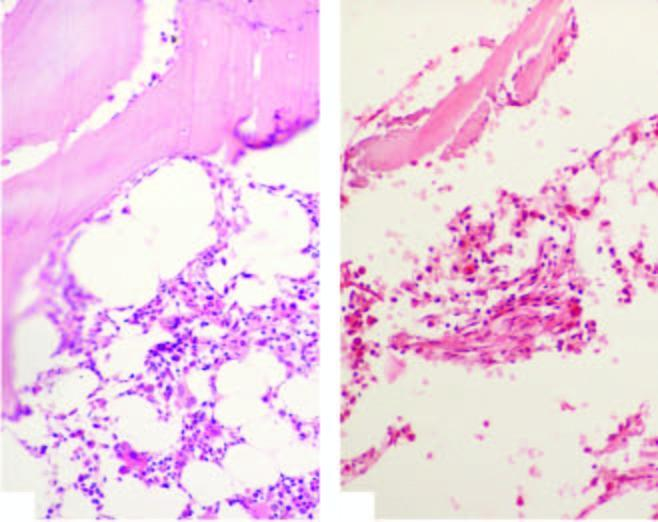what is contrasted against normal cellular marrow?
Answer the question using a single word or phrase. Against normal cellular marrow 